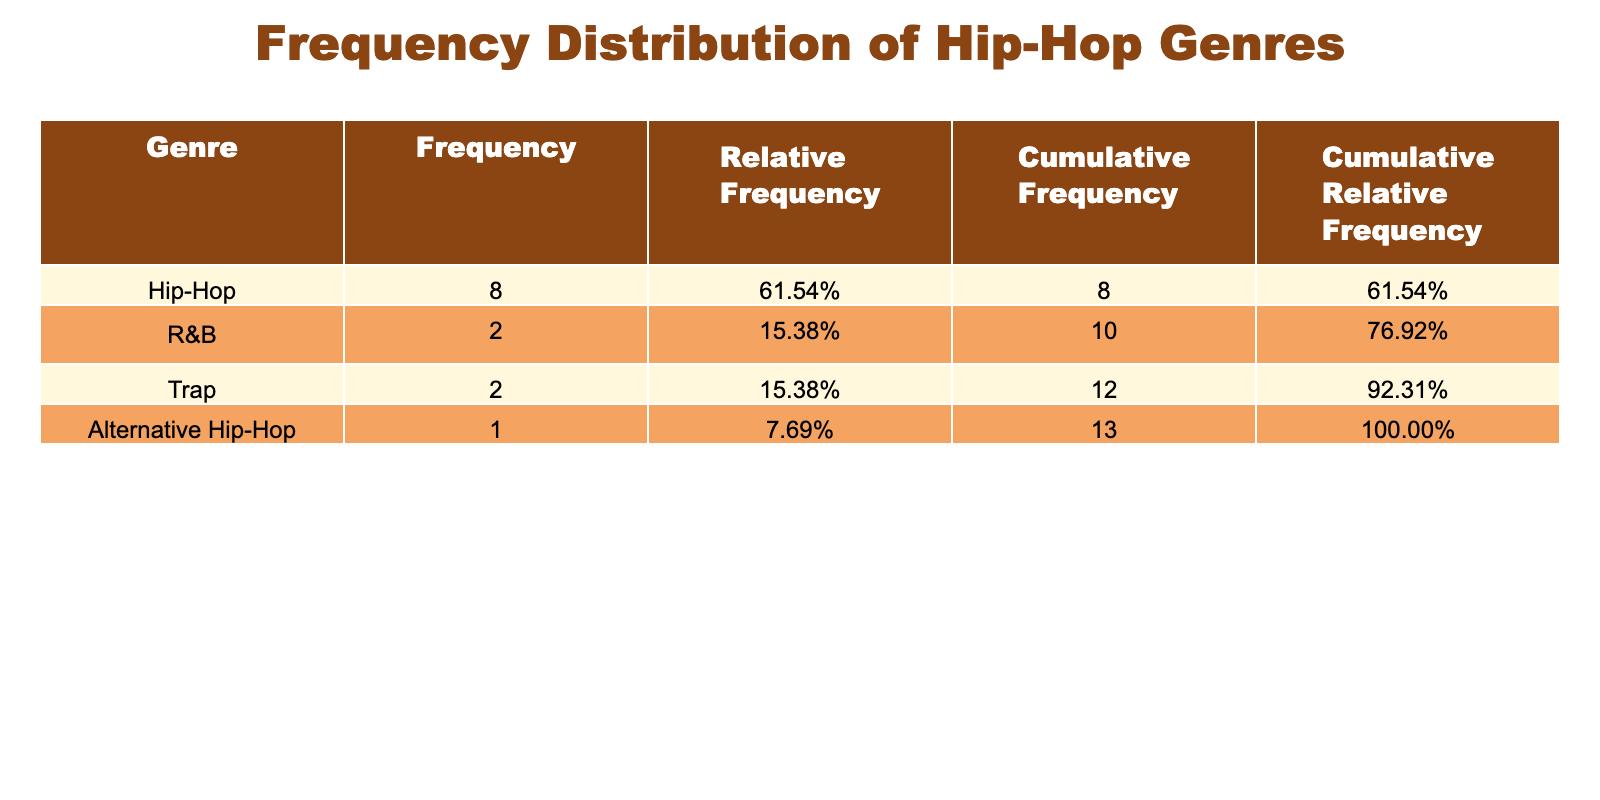What's the genre with the highest frequency of collaborations? The genre with the highest frequency is determined by looking at the frequency values listed in the table. By comparing the genres, Hip-Hop has the highest frequency at 46 collaborations.
Answer: Hip-Hop How many collaborations does Drake have? The table lists the number of collaborations for each artist. For Drake, the value is clearly indicated as 10 collaborations.
Answer: 10 What is the total number of collaborations in R&B? To find the total collaborations in R&B, we sum the collaborations of H.E.R. (2) and The Weeknd (3), giving us a total of 2 + 3 = 5.
Answer: 5 Is the statement "Travis Scott has more collaborations than Mac Miller" true? By looking at the collaboration counts in the table, Travis Scott has 8 collaborations, while Mac Miller has 4. Therefore, the statement is true.
Answer: Yes What is the total number of collaborations for artists in the Trap genre? The total for the Trap genre is calculated by adding the collaborations of Future (10) and Young Thug (4), resulting in 10 + 4 = 14.
Answer: 14 Which genre has a higher cumulative frequency, Hip-Hop or R&B? The cumulative frequency for Hip-Hop is 46, while for R&B, it is 5. By comparing these two values, Hip-Hop has a much higher cumulative frequency.
Answer: Hip-Hop How many more collaborations does Lil Wayne have than Post Malone? Lil Wayne has 9 collaborations and Post Malone has 3. The difference is calculated as 9 - 3 = 6, indicating Lil Wayne has 6 more collaborations.
Answer: 6 What is the average frequency of collaborations for artists in Alternative Hip-Hop? There is only one artist (Childish Gambino) in this genre with 4 collaborations. The average frequency, therefore, remains 4 since there are no additional artists to calculate.
Answer: 4 Is there any genre with exactly the same number of collaborations for different artists? Yes, both Travis Scott and J. Cole have collaborations totaling 8 and 7, but there are no genres tied for the same number of total collaborations.
Answer: No 